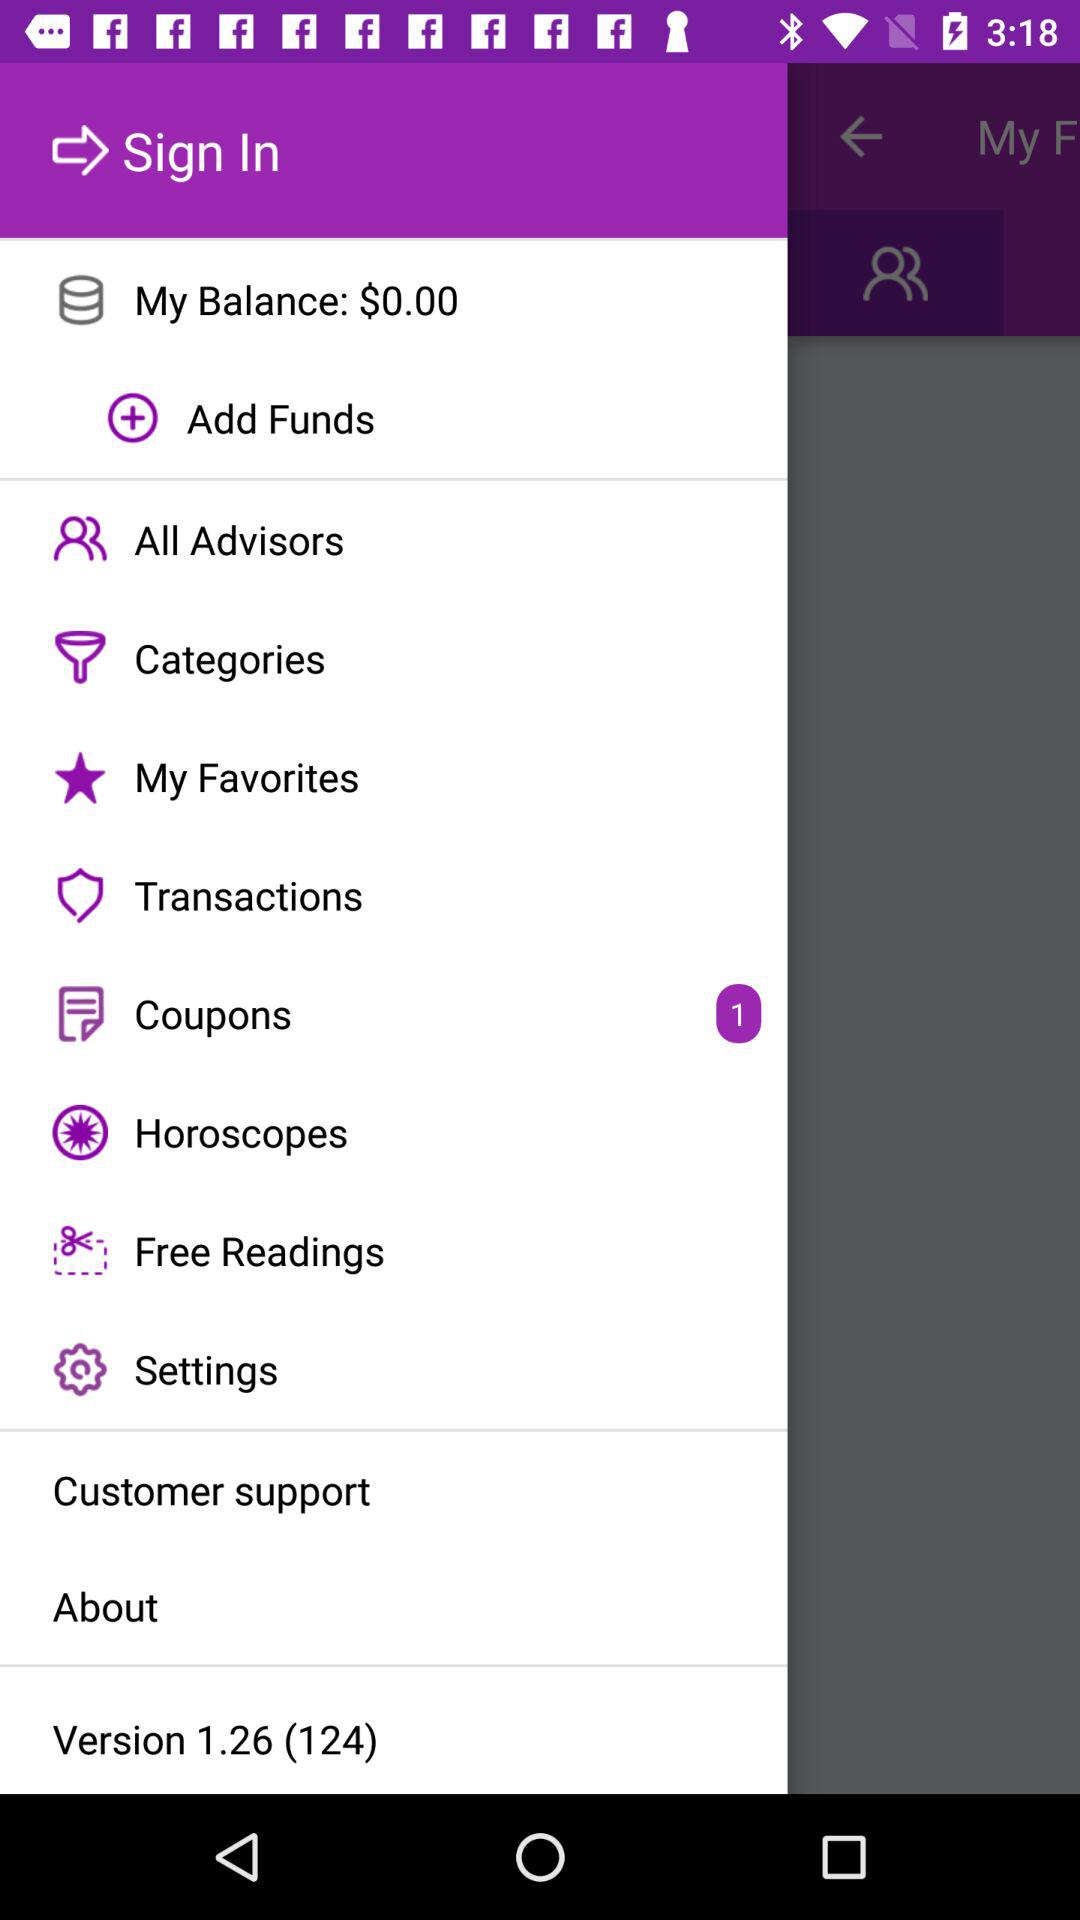What is the application's version number? The application's version number is 1.24 (124). 